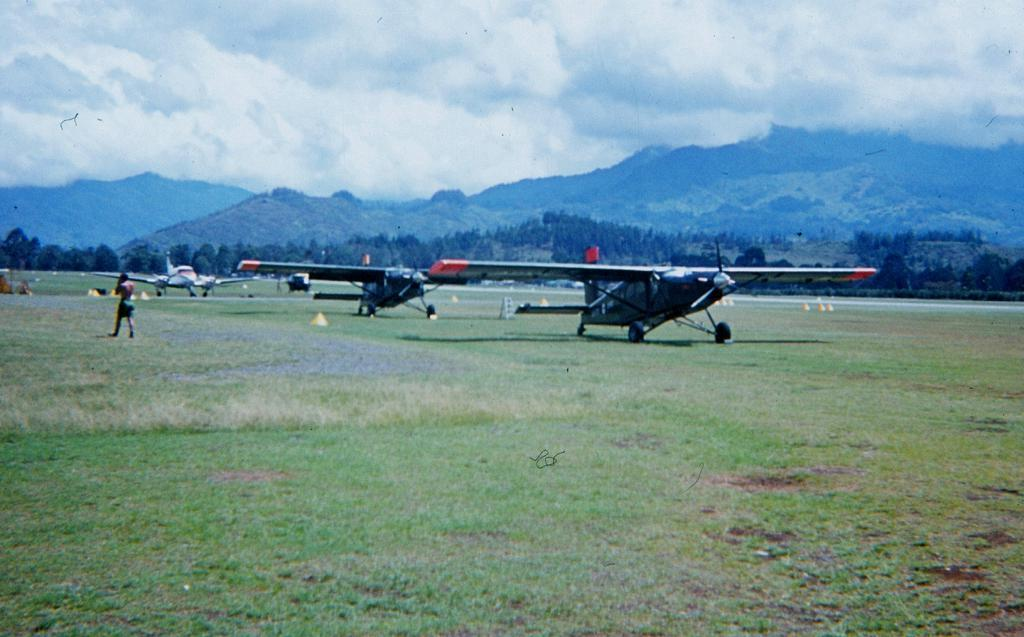What is the man in the image doing? There is a man walking in the image. What type of terrain can be seen in the image? There is grass in the image, and hills can be seen in the background. What can be seen in the sky in the image? The sky is visible at the top of the image, and clouds are present in the sky. What other objects or structures are in the image? There are planes and trees in the image. How many frogs are sitting on the man's elbow in the image? There are no frogs present in the image, and the man's elbow is not visible. 